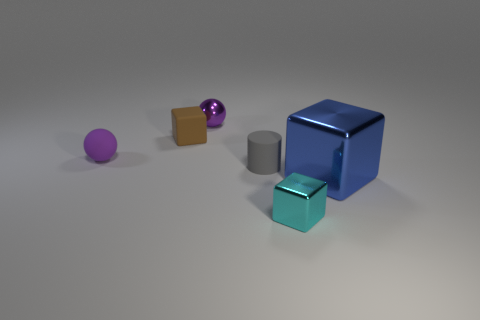Subtract 1 blocks. How many blocks are left? 2 Subtract all metal cubes. How many cubes are left? 1 Add 2 large yellow rubber balls. How many objects exist? 8 Subtract all cylinders. How many objects are left? 5 Subtract all brown cubes. Subtract all purple shiny balls. How many objects are left? 4 Add 2 tiny metallic spheres. How many tiny metallic spheres are left? 3 Add 2 small yellow cylinders. How many small yellow cylinders exist? 2 Subtract 2 purple balls. How many objects are left? 4 